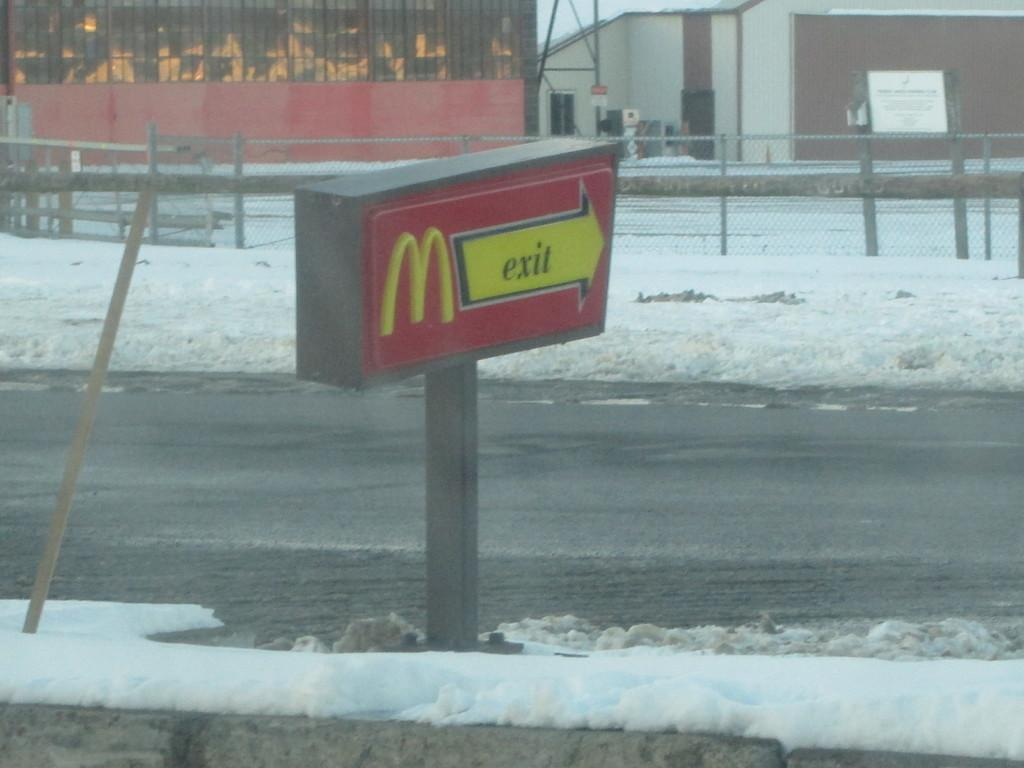<image>
Write a terse but informative summary of the picture. The sign from the drive through says exit 